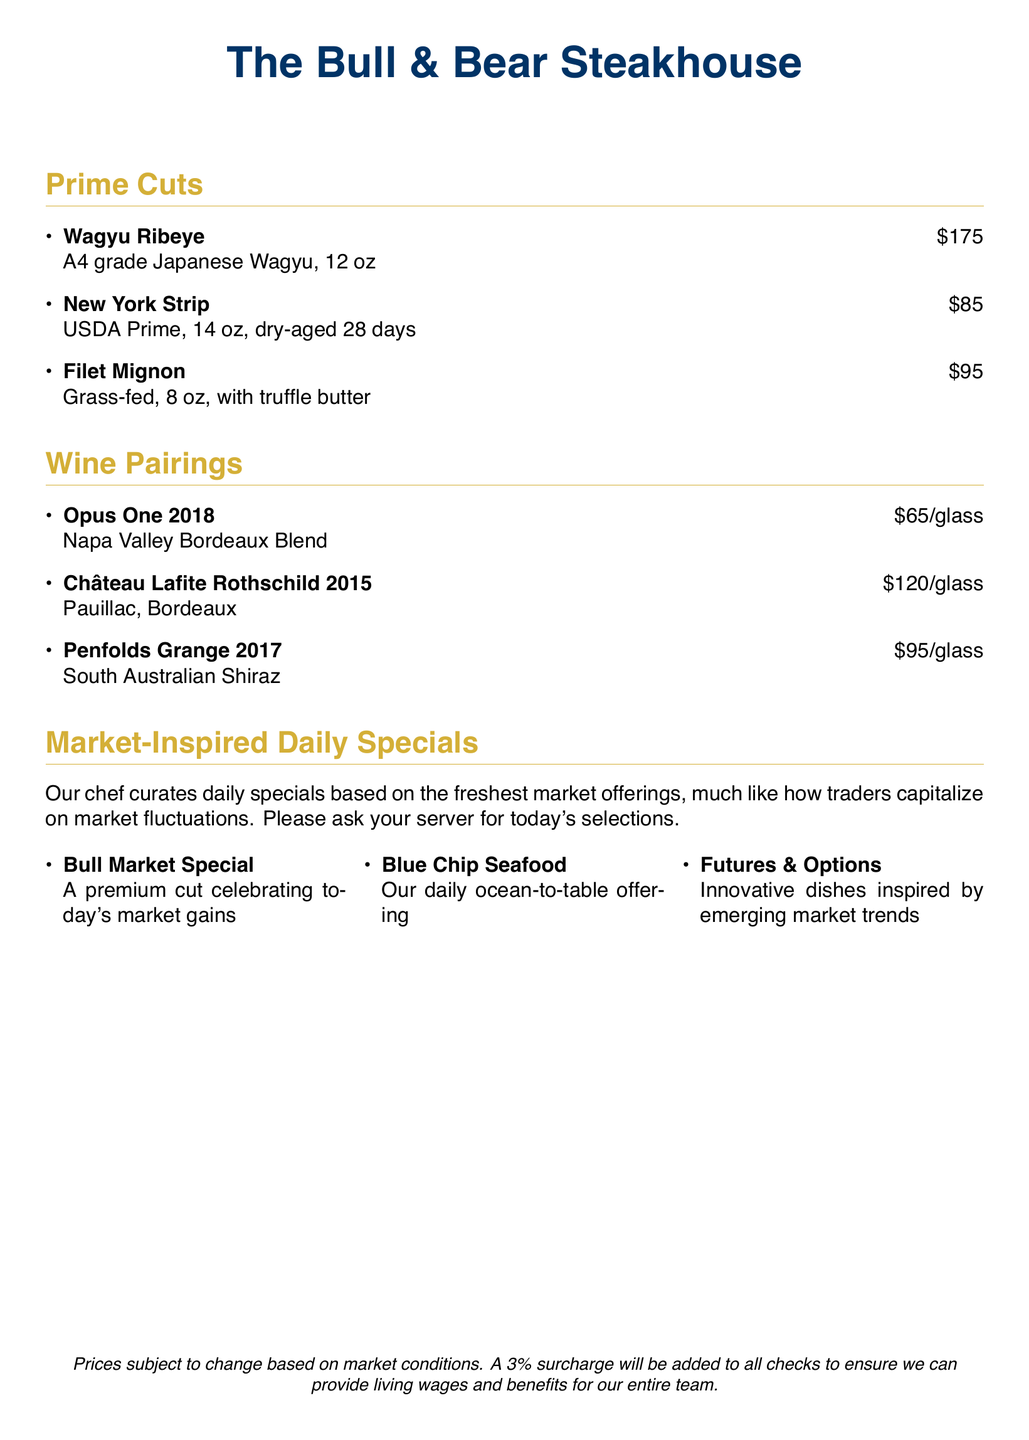What is the price of the Wagyu Ribeye? The price of the Wagyu Ribeye is listed under the Prime Cuts section as $175.
Answer: $175 How long is the New York Strip aged? The New York Strip is dry-aged for 28 days, as stated in the description.
Answer: 28 days What type of wine is Opus One? Opus One is a Napa Valley Bordeaux Blend, which is noted in the Wine Pairings section.
Answer: Napa Valley Bordeaux Blend What is the special for a Bull Market? The Bull Market Special is a premium cut celebrating today's market gains, as mentioned in the market-inspired specials.
Answer: A premium cut celebrating today's market gains How much is the glass of Château Lafite Rothschild? The price for a glass of Château Lafite Rothschild is provided in the Wine Pairings section as $120.
Answer: $120 What is required to be added to all checks? The document states that a 3% surcharge will be added to all checks for living wages and benefits.
Answer: 3% surcharge What type of offering is Blue Chip Seafood? Blue Chip Seafood is described as the daily ocean-to-table offering in the menu.
Answer: Daily ocean-to-table offering How many ounces is the Filet Mignon? The Filet Mignon is described as being 8 oz in size under the Prime Cuts section.
Answer: 8 oz 